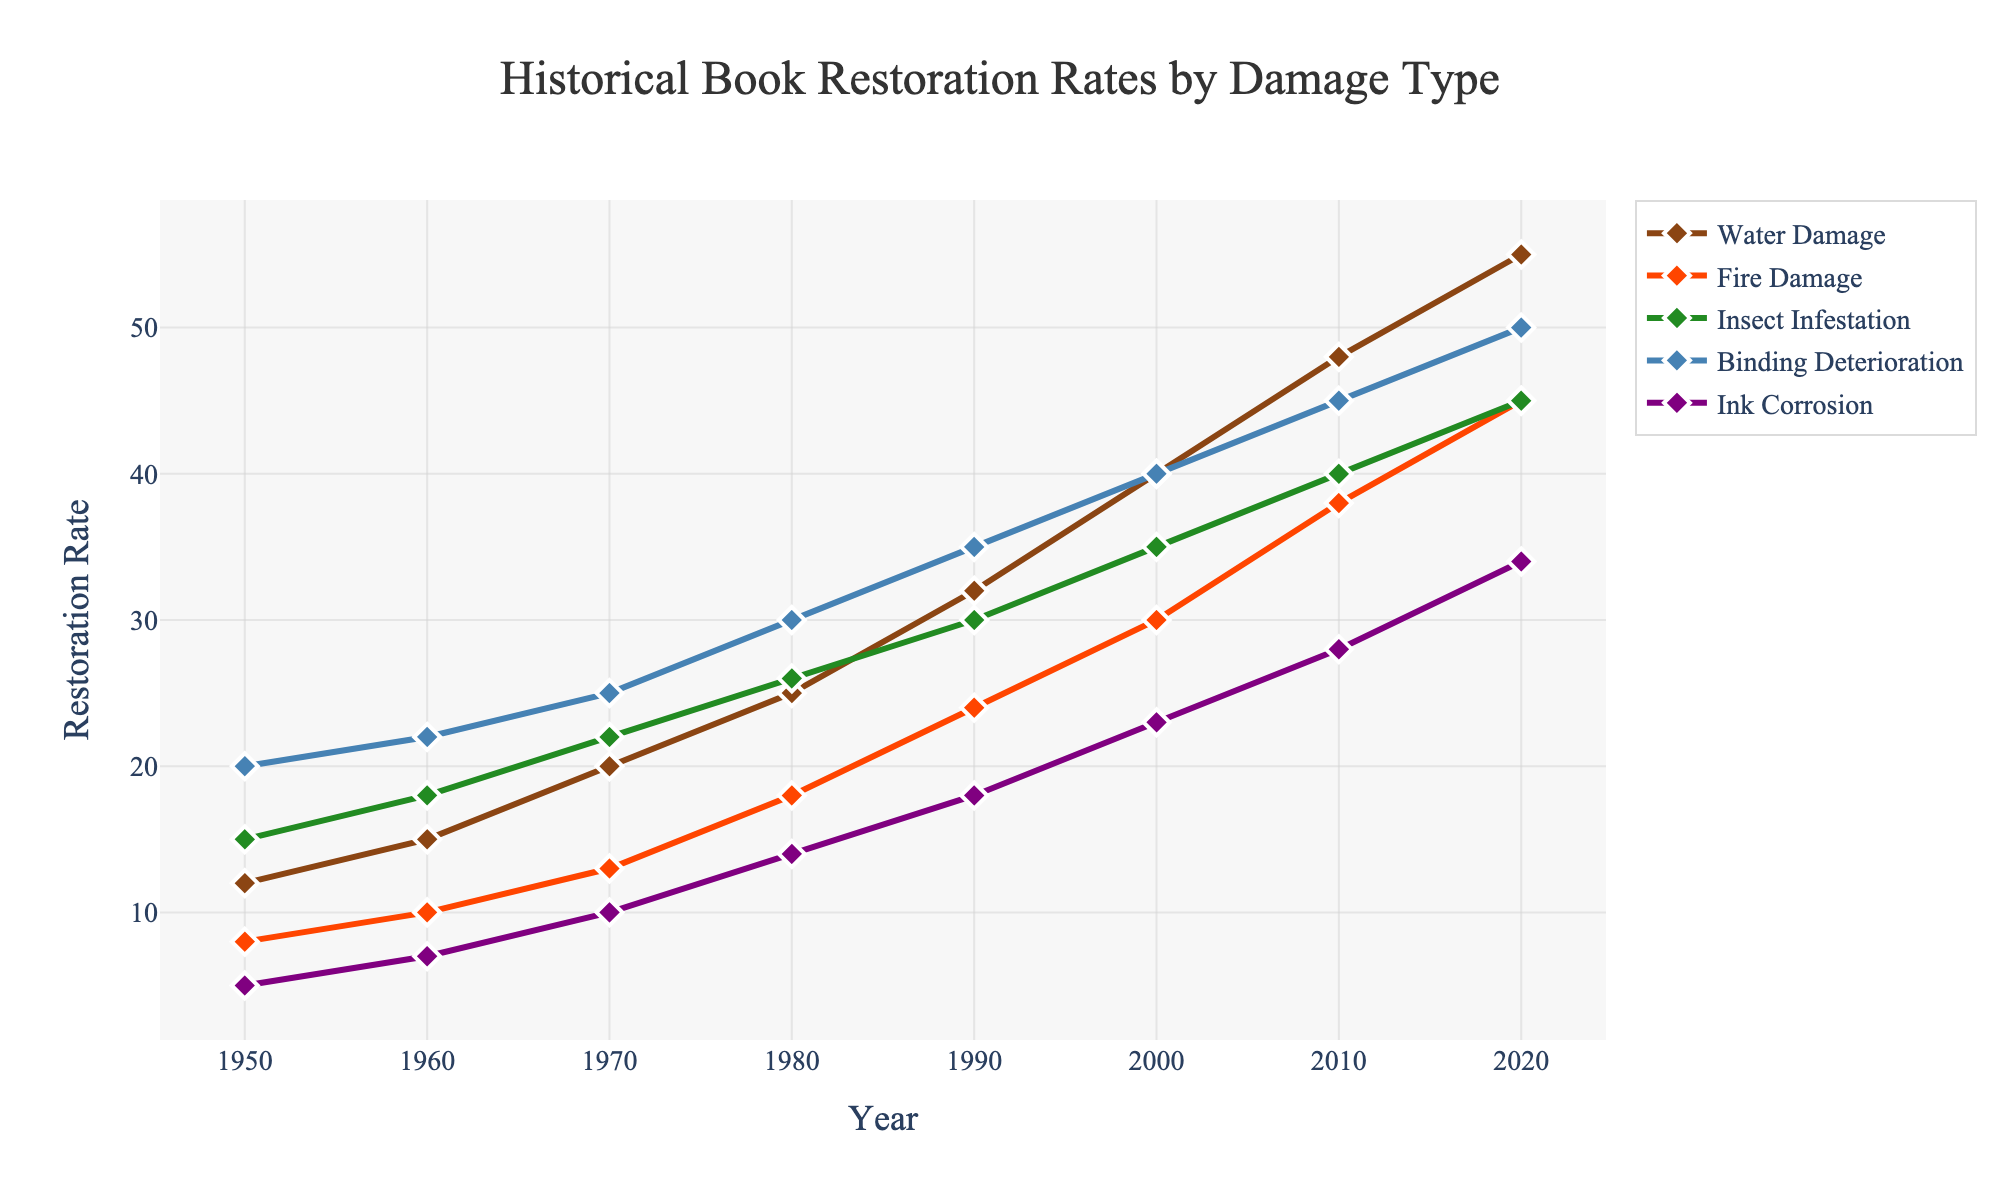What year saw the highest restoration rate for Fire Damage? The line for Fire Damage shows an increasing trend and peaks at 2020.
Answer: 2020 What is the combined restoration rate for Water Damage and Binding Deterioration in 1990? In 1990, the Water Damage rate is 32, and the Binding Deterioration rate is 35. Adding them together gives 32 + 35.
Answer: 67 Which damage type had the slowest growth in restoration rates from 1950 to 2020? By examining the slopes of the lines from 1950 to 2020, Ink Corrosion shows the slowest increase compared to the others.
Answer: Ink Corrosion Which damage type exceeds a restoration rate of 40 first? Looking at the y-values along the x-axis, Water Damage is the first to cross the 40 mark by 2000.
Answer: Water Damage How does the trend of Insect Infestation restoration rates compare to Binding Deterioration between 1970 and 2000? Between 1970 and 2000, Insect Infestation increases steadily from 22 to 35, while Binding Deterioration also increases steadily but with larger values, from 25 to 40. That shows that while both trends increase, Binding Deterioration does so at a marginally higher rate.
Answer: Both increase; Binding Deterioration grows faster Between which consecutive decades did Water Damage restoration rates see the highest increase? To find this, we need to calculate the differences between each consecutive decay: 1960-1950 (3), 1970-1960 (5), 1980-1970 (5), 1990-1980 (7), 2000-1990 (8), 2010-2000 (8), and 2020-2010 (7). The greatest difference is found in the intervals 1990-2000 and 2000-2010, both having risen by 8.
Answer: 1990-2000, 2000-2010 What are the restoration rates of Ink Corrosion in 1970 and 2000 and their difference? The restoration rate of Ink Corrosion in 1970 was 10 and in 2000 was 23. Taking the difference gives 23 - 10.
Answer: 13 Which damage type shows the most drastic increase between 2010 and 2020? Comparing the slopes between these two points, both Water Damage (48 to 55, increase of 7) and Insect Infestation (40 to 45, increase of 5) are significant, but Water Damage shows a bigger increase.
Answer: Water Damage 